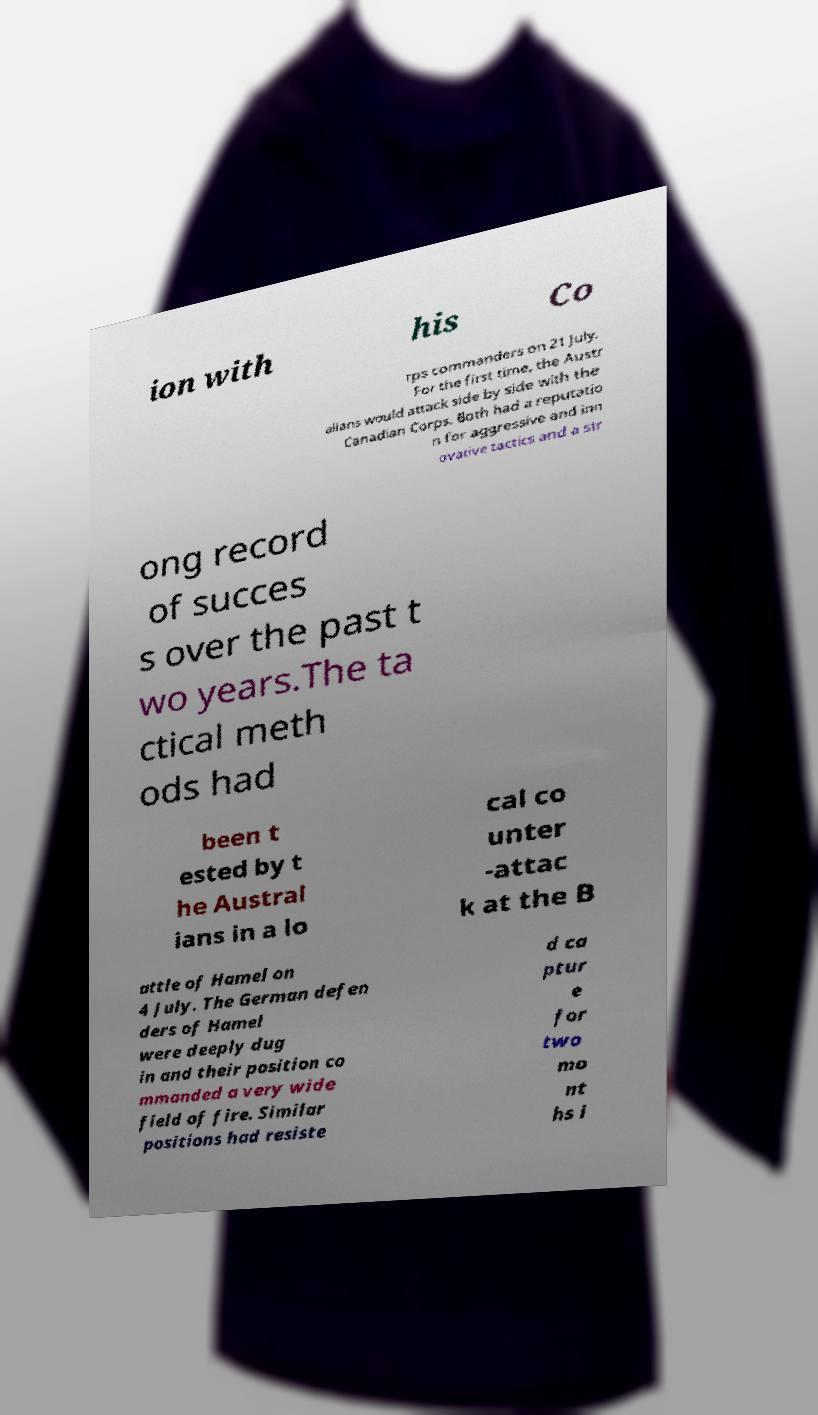Could you assist in decoding the text presented in this image and type it out clearly? ion with his Co rps commanders on 21 July. For the first time, the Austr alians would attack side by side with the Canadian Corps. Both had a reputatio n for aggressive and inn ovative tactics and a str ong record of succes s over the past t wo years.The ta ctical meth ods had been t ested by t he Austral ians in a lo cal co unter -attac k at the B attle of Hamel on 4 July. The German defen ders of Hamel were deeply dug in and their position co mmanded a very wide field of fire. Similar positions had resiste d ca ptur e for two mo nt hs i 